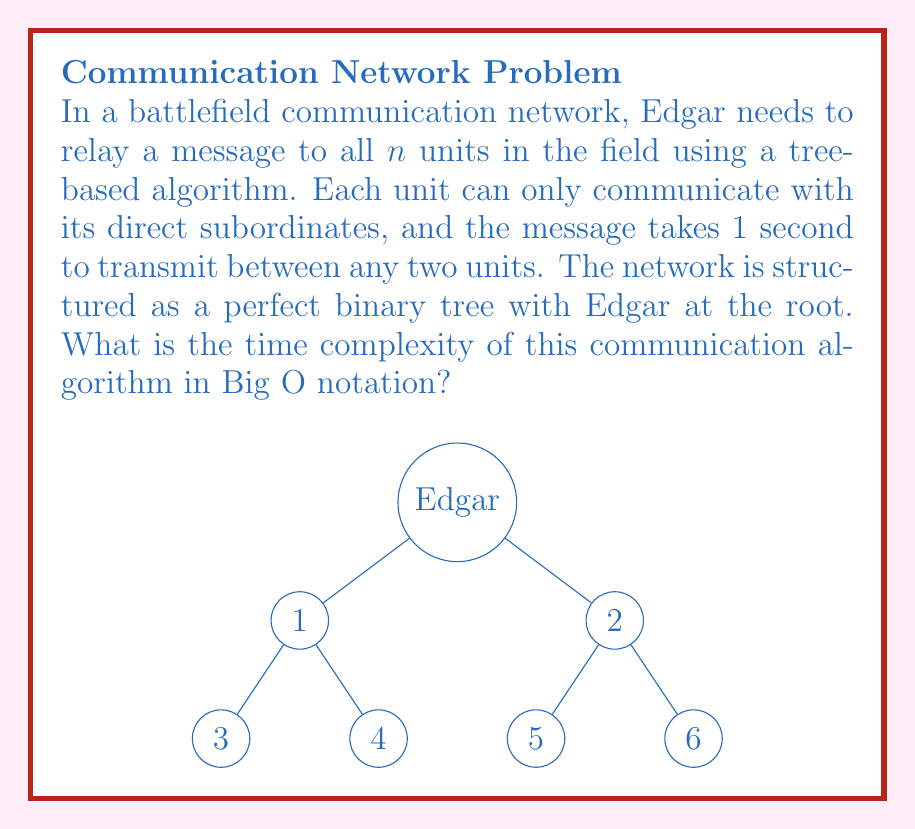Can you answer this question? Let's analyze this step-by-step:

1) In a perfect binary tree, each node (except leaf nodes) has exactly two children.

2) The height of a perfect binary tree with $n$ nodes is $\log_2(n+1) - 1$.

3) In this communication network, the time taken for the message to reach all units is equal to the height of the tree, as the message needs to travel from the root (Edgar) to the deepest leaf node.

4) Let's express the time $T(n)$ as a function of the number of units $n$:

   $T(n) = \log_2(n+1) - 1$

5) In Big O notation, we're interested in the growth rate as $n$ becomes large. The constant -1 becomes insignificant, and we can simplify:

   $T(n) \in O(\log_2(n))$

6) In algorithm analysis, we typically express logarithms in base 2 simply as $\log n$, as the base only affects the time complexity by a constant factor, which is ignored in Big O notation.

Therefore, the time complexity of this battlefield communication algorithm is $O(\log n)$.
Answer: $O(\log n)$ 